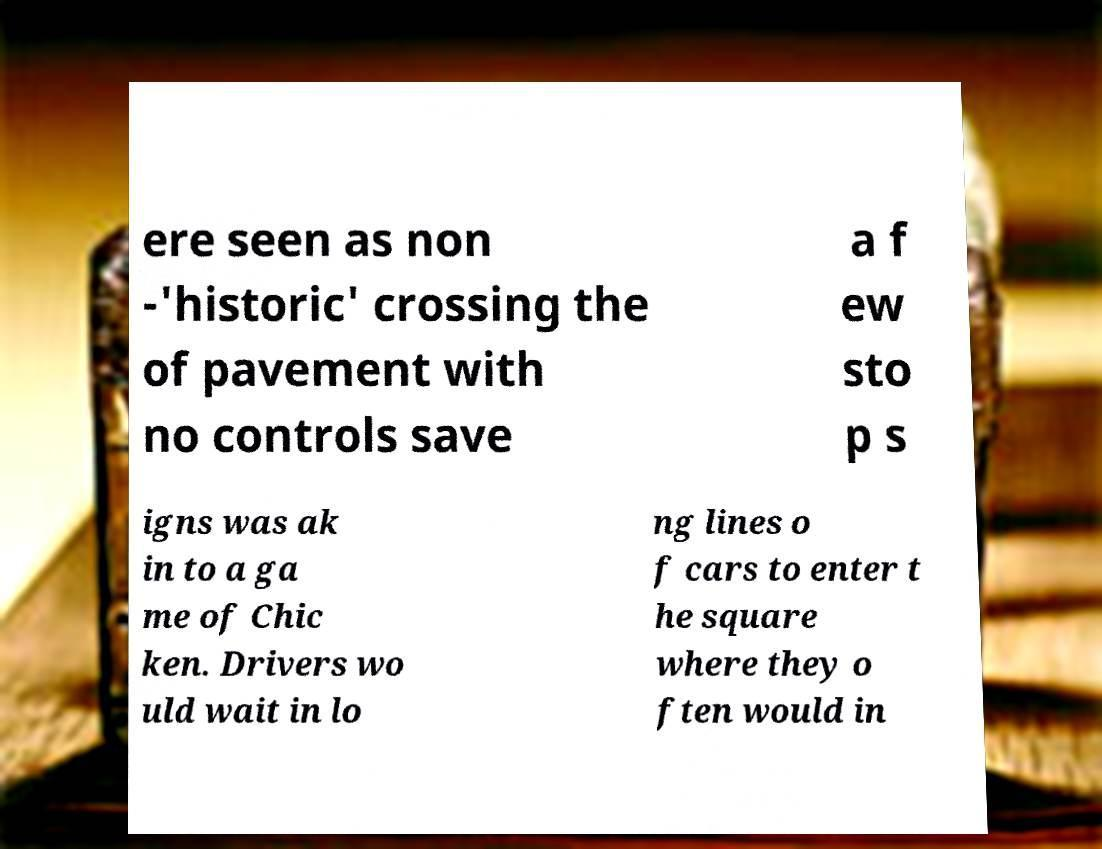There's text embedded in this image that I need extracted. Can you transcribe it verbatim? ere seen as non -'historic' crossing the of pavement with no controls save a f ew sto p s igns was ak in to a ga me of Chic ken. Drivers wo uld wait in lo ng lines o f cars to enter t he square where they o ften would in 